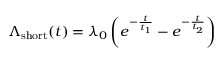Convert formula to latex. <formula><loc_0><loc_0><loc_500><loc_500>\Lambda _ { s h o r t } ( t ) = \lambda _ { 0 } \left ( e ^ { - \frac { t } { t _ { 1 } } } - e ^ { - \frac { t } { t _ { 2 } } } \right )</formula> 